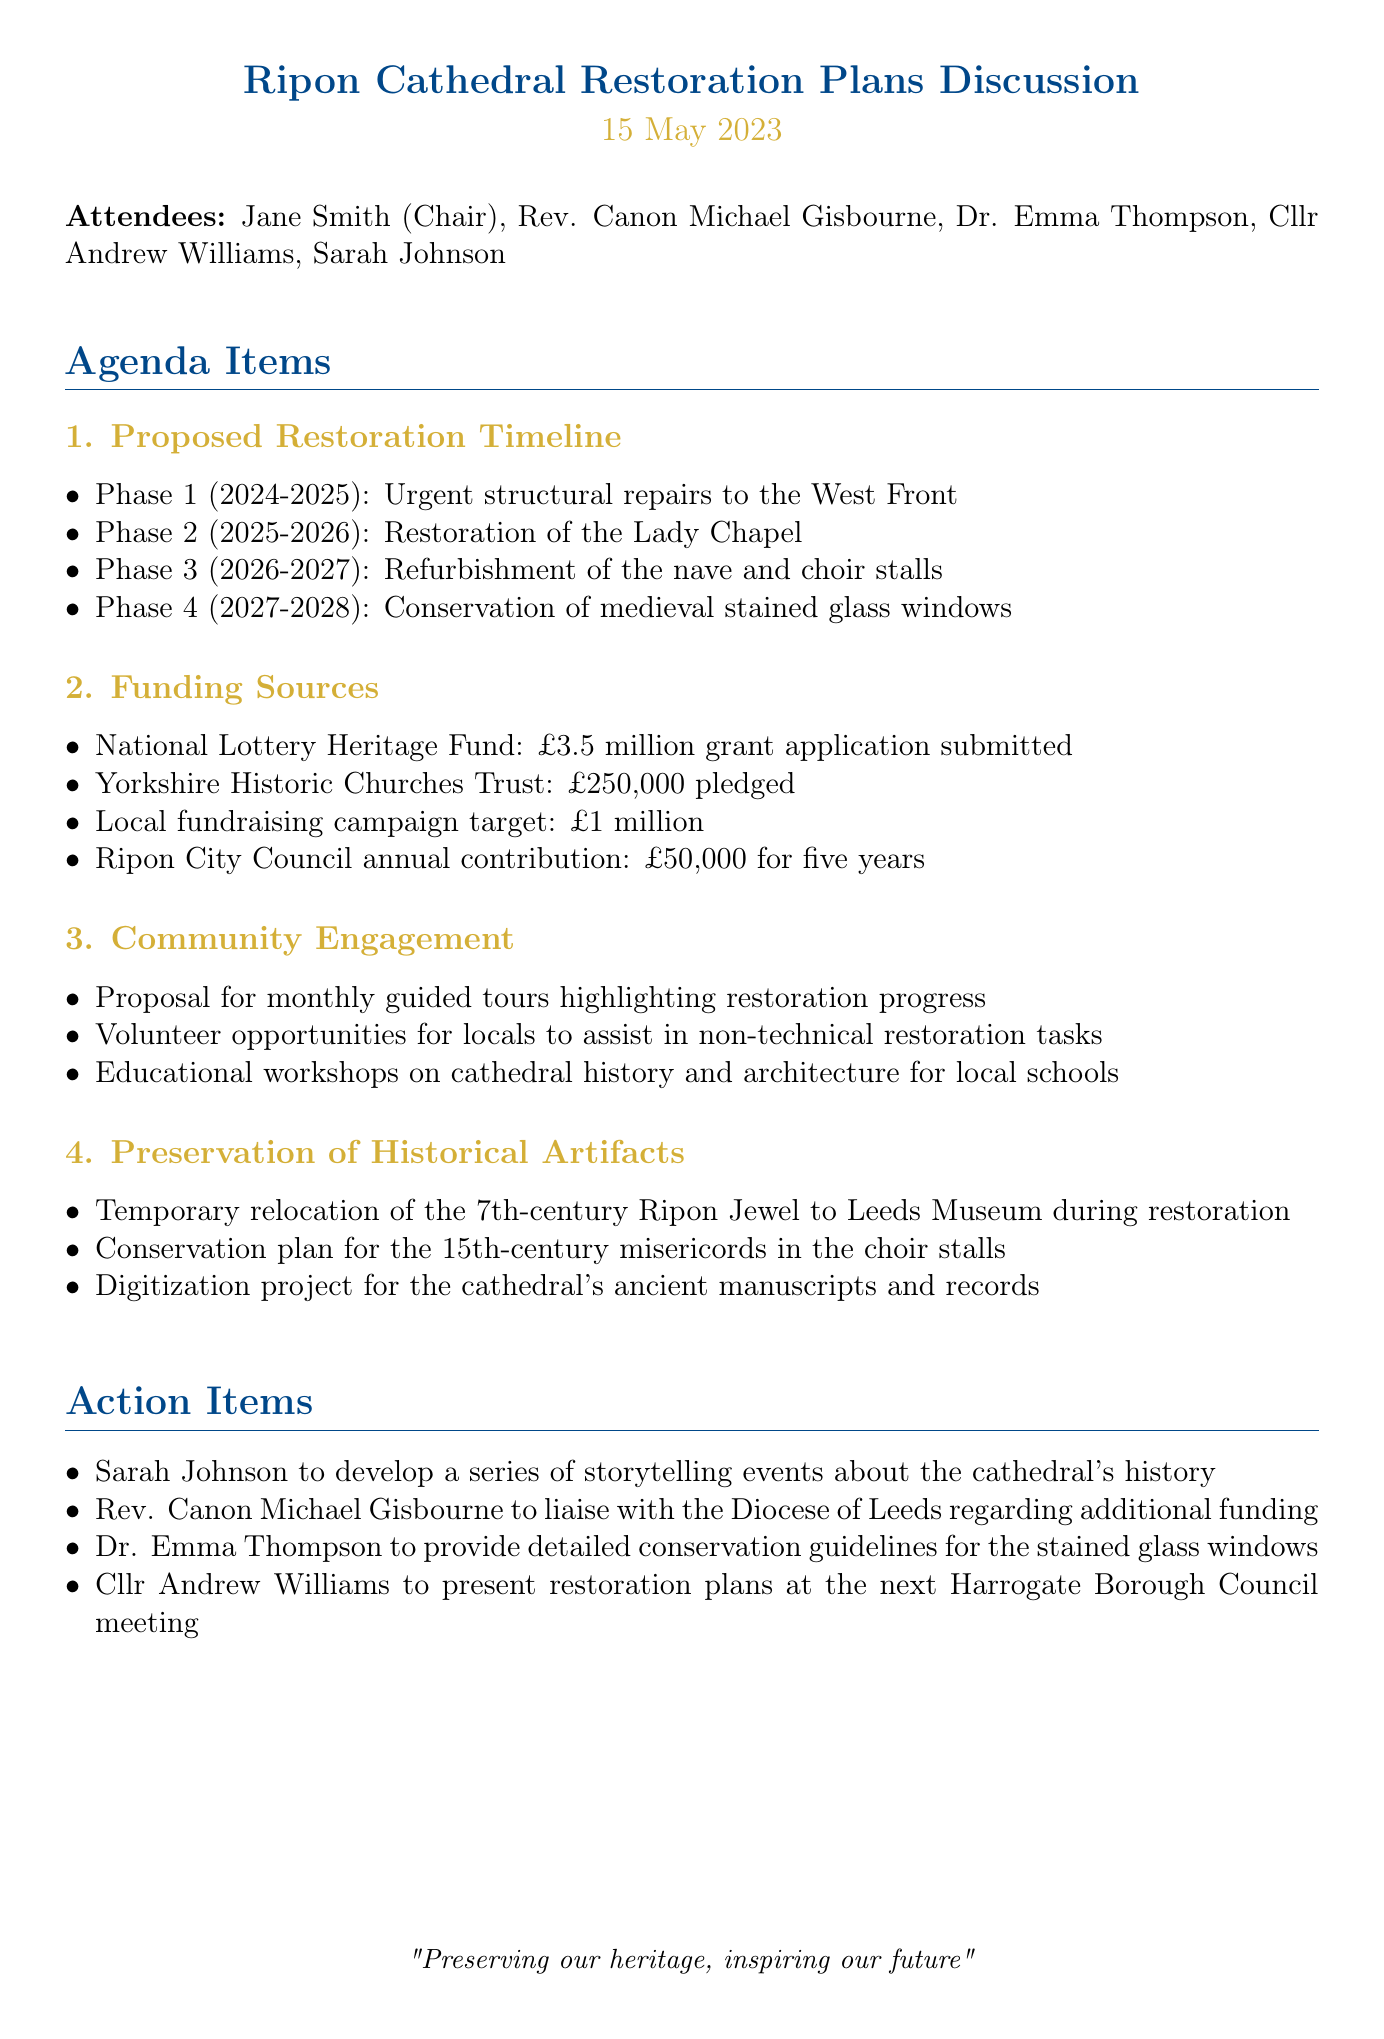What is the date of the meeting? The date of the meeting is clearly stated at the beginning of the document.
Answer: 15 May 2023 Who is the Chair of the Ripon Cathedral Preservation Society? The document specifies Jane Smith as the Chair during the meeting.
Answer: Jane Smith How much funding is being requested from the National Lottery Heritage Fund? The details in the funding sources section mention the amount requested from this source.
Answer: £3.5 million What phase involves the refurbishment of the nave and choir stalls? The phase details in the document outline the activities for each restoration phase.
Answer: Phase 3 How long is the Ripon City Council's annual contribution planned for? The action item discusses the duration of the council's funding commitment.
Answer: Five years What community engagement activity is proposed to highlight restoration progress? The community engagement section lays out different activities aimed at involving the public.
Answer: Monthly guided tours What will Sarah Johnson develop concerning the cathedral? One of the action items specifies what Sarah Johnson is tasked with developing.
Answer: Storytelling events Which historical artifact is temporarily relocated during restoration? The preservation section notes the temporary movement of an important artifact during the restoration process.
Answer: Ripon Jewel What is the funding target for the local fundraising campaign? The document provides a specific target amount for fundraising efforts in the funding sources section.
Answer: £1 million 